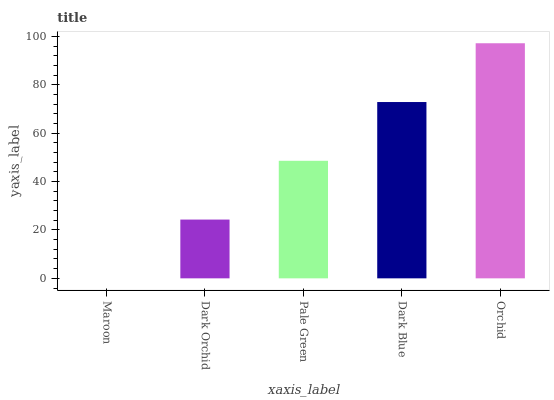Is Maroon the minimum?
Answer yes or no. Yes. Is Orchid the maximum?
Answer yes or no. Yes. Is Dark Orchid the minimum?
Answer yes or no. No. Is Dark Orchid the maximum?
Answer yes or no. No. Is Dark Orchid greater than Maroon?
Answer yes or no. Yes. Is Maroon less than Dark Orchid?
Answer yes or no. Yes. Is Maroon greater than Dark Orchid?
Answer yes or no. No. Is Dark Orchid less than Maroon?
Answer yes or no. No. Is Pale Green the high median?
Answer yes or no. Yes. Is Pale Green the low median?
Answer yes or no. Yes. Is Dark Blue the high median?
Answer yes or no. No. Is Dark Orchid the low median?
Answer yes or no. No. 